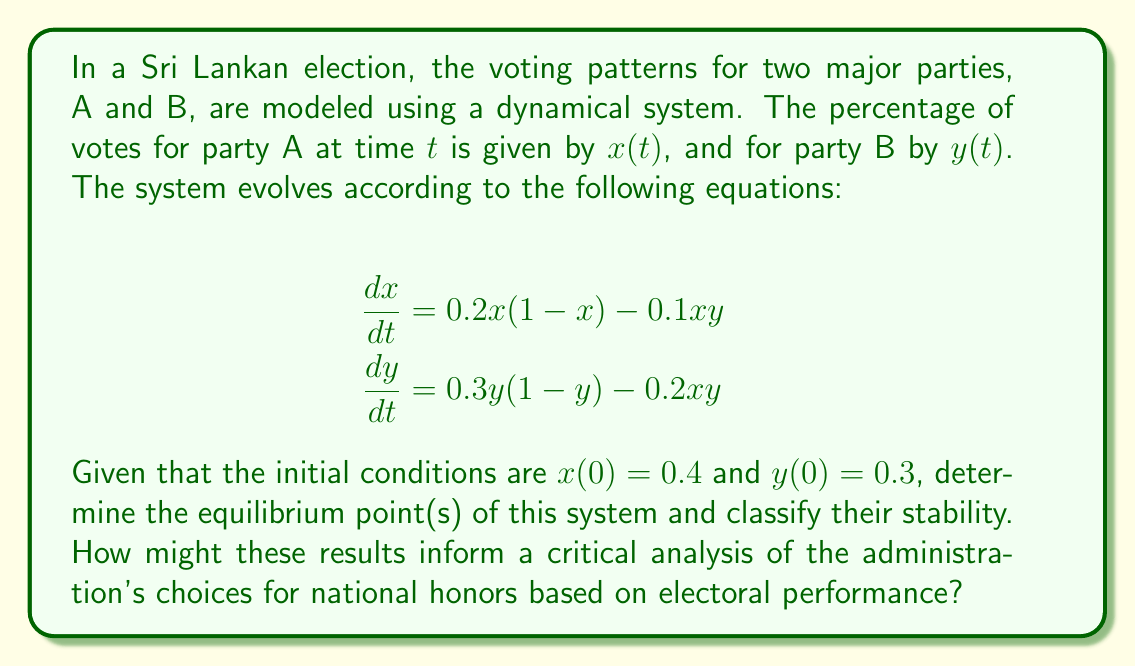Help me with this question. To solve this problem, we'll follow these steps:

1) Find the equilibrium points by setting $\frac{dx}{dt} = 0$ and $\frac{dy}{dt} = 0$:

   $$0.2x(1-x) - 0.1xy = 0$$
   $$0.3y(1-y) - 0.2xy = 0$$

2) Solve these equations:
   From the first equation:
   $$x(0.2 - 0.2x - 0.1y) = 0$$
   So either $x = 0$, or $0.2 - 0.2x - 0.1y = 0$

   From the second equation:
   $$y(0.3 - 0.3y - 0.2x) = 0$$
   So either $y = 0$, or $0.3 - 0.3y - 0.2x = 0$

3) This gives us four possible equilibrium points:
   (0,0), (1,0), (0,1), and the intersection of the lines:
   $$0.2 - 0.2x - 0.1y = 0$$
   $$0.3 - 0.3y - 0.2x = 0$$

4) Solving these simultaneously:
   $$x = 0.5, y = 0.5$$

5) To classify stability, we need to find the Jacobian matrix:

   $$J = \begin{bmatrix}
   0.2 - 0.4x - 0.1y & -0.1x \\
   -0.2y & 0.3 - 0.6y - 0.2x
   \end{bmatrix}$$

6) Evaluate the Jacobian at each equilibrium point and find its eigenvalues:

   At (0,0): $J = \begin{bmatrix} 0.2 & 0 \\ 0 & 0.3 \end{bmatrix}$
   Eigenvalues: 0.2 and 0.3 (both positive, unstable node)

   At (1,0): $J = \begin{bmatrix} -0.2 & -0.1 \\ 0 & 0.1 \end{bmatrix}$
   Eigenvalues: -0.2 and 0.1 (saddle point)

   At (0,1): $J = \begin{bmatrix} 0.1 & 0 \\ -0.2 & -0.3 \end{bmatrix}$
   Eigenvalues: 0.1 and -0.3 (saddle point)

   At (0.5,0.5): $J = \begin{bmatrix} -0.05 & -0.05 \\ -0.1 & -0.1 \end{bmatrix}$
   Eigenvalues: -0.15 and 0 (neutrally stable)

7) The equilibrium point (0.5,0.5) represents a state where both parties have equal support. Its neutral stability suggests that small perturbations won't cause significant changes, but larger disturbances could shift the system to favor one party over the other.

This analysis could inform a critical view of the administration's choices for national honors by highlighting the delicate balance in the political landscape. The existence of multiple equilibrium points, including unstable ones, suggests that the system can be easily influenced. The administration might be using national honors to manipulate this balance, potentially favoring one party over another in an attempt to push the system towards a desired equilibrium.
Answer: Equilibrium points: (0,0), (1,0), (0,1), (0.5,0.5). (0,0) is unstable, (1,0) and (0,1) are saddle points, (0.5,0.5) is neutrally stable. 